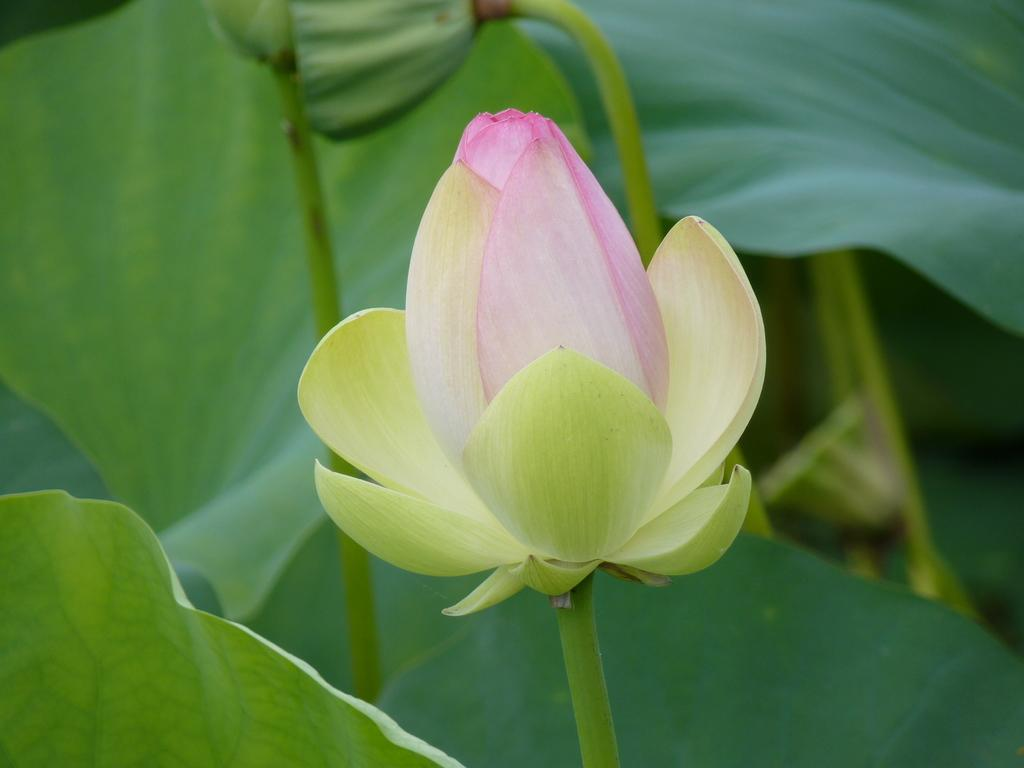What is the main subject in the middle of the image? There is a flower in the middle of the image. What can be seen surrounding the flower? There are green leaves surrounding the flower. What type of activity is the brick participating in with the flower in the image? There is no brick present in the image, so it cannot be involved in any activity with the flower. 